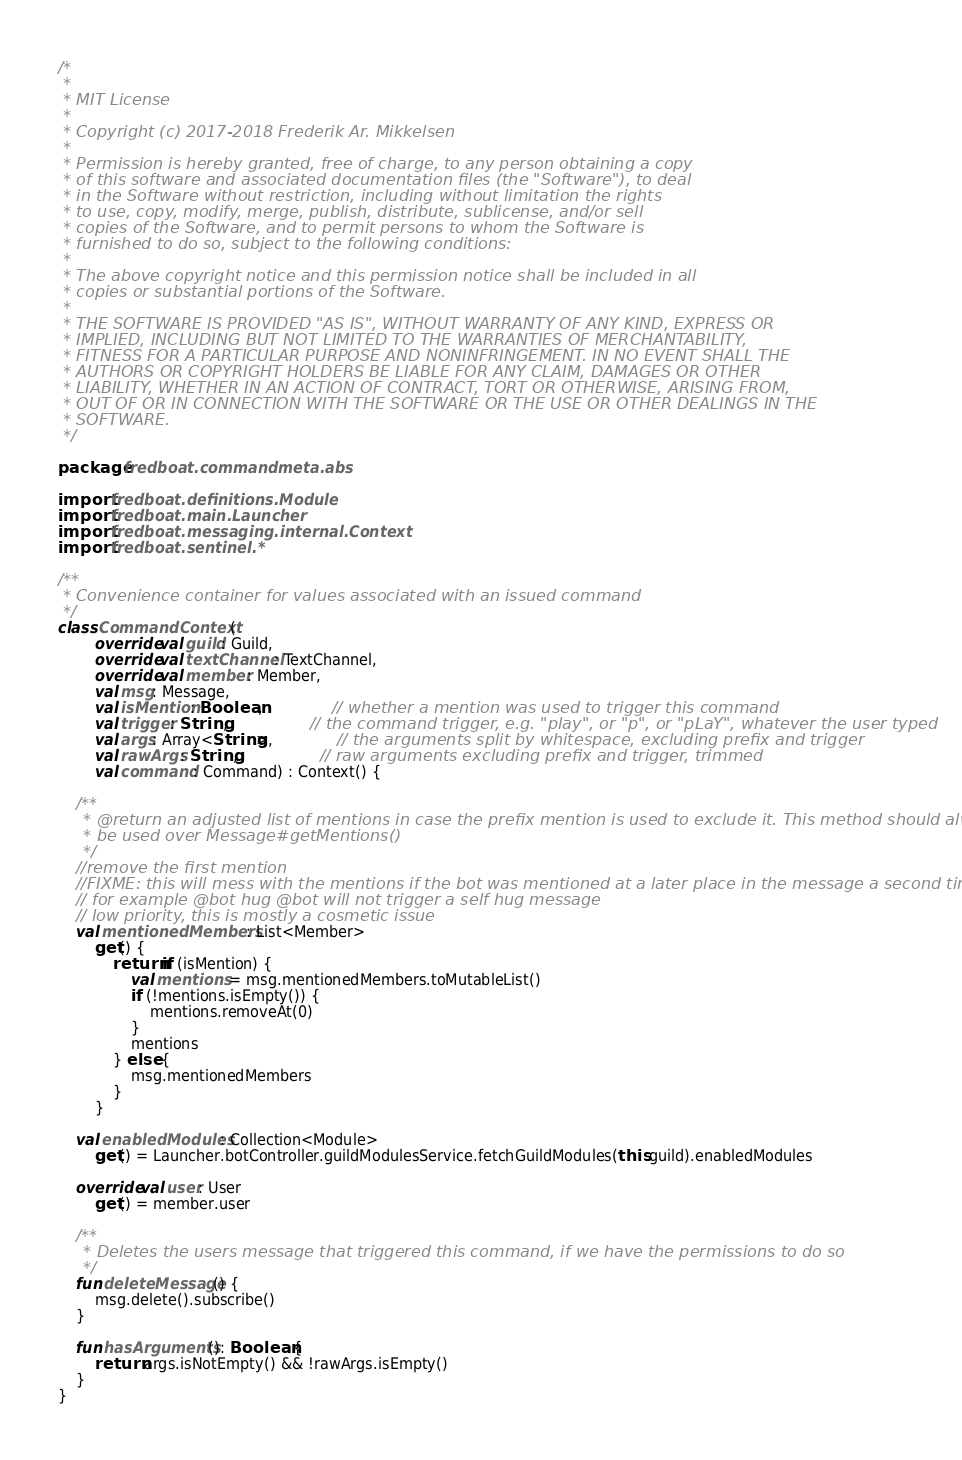Convert code to text. <code><loc_0><loc_0><loc_500><loc_500><_Kotlin_>/*
 *
 * MIT License
 *
 * Copyright (c) 2017-2018 Frederik Ar. Mikkelsen
 *
 * Permission is hereby granted, free of charge, to any person obtaining a copy
 * of this software and associated documentation files (the "Software"), to deal
 * in the Software without restriction, including without limitation the rights
 * to use, copy, modify, merge, publish, distribute, sublicense, and/or sell
 * copies of the Software, and to permit persons to whom the Software is
 * furnished to do so, subject to the following conditions:
 *
 * The above copyright notice and this permission notice shall be included in all
 * copies or substantial portions of the Software.
 *
 * THE SOFTWARE IS PROVIDED "AS IS", WITHOUT WARRANTY OF ANY KIND, EXPRESS OR
 * IMPLIED, INCLUDING BUT NOT LIMITED TO THE WARRANTIES OF MERCHANTABILITY,
 * FITNESS FOR A PARTICULAR PURPOSE AND NONINFRINGEMENT. IN NO EVENT SHALL THE
 * AUTHORS OR COPYRIGHT HOLDERS BE LIABLE FOR ANY CLAIM, DAMAGES OR OTHER
 * LIABILITY, WHETHER IN AN ACTION OF CONTRACT, TORT OR OTHERWISE, ARISING FROM,
 * OUT OF OR IN CONNECTION WITH THE SOFTWARE OR THE USE OR OTHER DEALINGS IN THE
 * SOFTWARE.
 */

package fredboat.commandmeta.abs

import fredboat.definitions.Module
import fredboat.main.Launcher
import fredboat.messaging.internal.Context
import fredboat.sentinel.*

/**
 * Convenience container for values associated with an issued command
 */
class CommandContext(
        override val guild: Guild,
        override val textChannel: TextChannel,
        override val member: Member,
        val msg: Message,
        val isMention: Boolean,               // whether a mention was used to trigger this command
        val trigger: String,                  // the command trigger, e.g. "play", or "p", or "pLaY", whatever the user typed
        val args: Array<String>,              // the arguments split by whitespace, excluding prefix and trigger
        val rawArgs: String,                  // raw arguments excluding prefix and trigger, trimmed
        val command: Command) : Context() {

    /**
     * @return an adjusted list of mentions in case the prefix mention is used to exclude it. This method should always
     * be used over Message#getMentions()
     */
    //remove the first mention
    //FIXME: this will mess with the mentions if the bot was mentioned at a later place in the message a second time,
    // for example @bot hug @bot will not trigger a self hug message
    // low priority, this is mostly a cosmetic issue
    val mentionedMembers: List<Member>
        get() {
            return if (isMention) {
                val mentions = msg.mentionedMembers.toMutableList()
                if (!mentions.isEmpty()) {
                    mentions.removeAt(0)
                }
                mentions
            } else {
                msg.mentionedMembers
            }
        }

    val enabledModules: Collection<Module>
        get() = Launcher.botController.guildModulesService.fetchGuildModules(this.guild).enabledModules

    override val user: User
        get() = member.user

    /**
     * Deletes the users message that triggered this command, if we have the permissions to do so
     */
    fun deleteMessage() {
        msg.delete().subscribe()
    }

    fun hasArguments(): Boolean {
        return args.isNotEmpty() && !rawArgs.isEmpty()
    }
}
</code> 